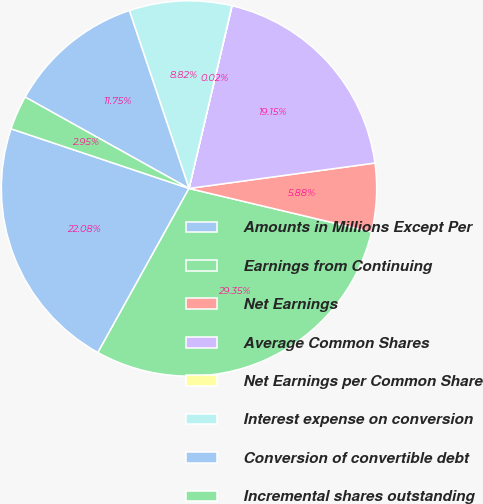Convert chart. <chart><loc_0><loc_0><loc_500><loc_500><pie_chart><fcel>Amounts in Millions Except Per<fcel>Earnings from Continuing<fcel>Net Earnings<fcel>Average Common Shares<fcel>Net Earnings per Common Share<fcel>Interest expense on conversion<fcel>Conversion of convertible debt<fcel>Incremental shares outstanding<nl><fcel>22.08%<fcel>29.35%<fcel>5.88%<fcel>19.15%<fcel>0.02%<fcel>8.82%<fcel>11.75%<fcel>2.95%<nl></chart> 